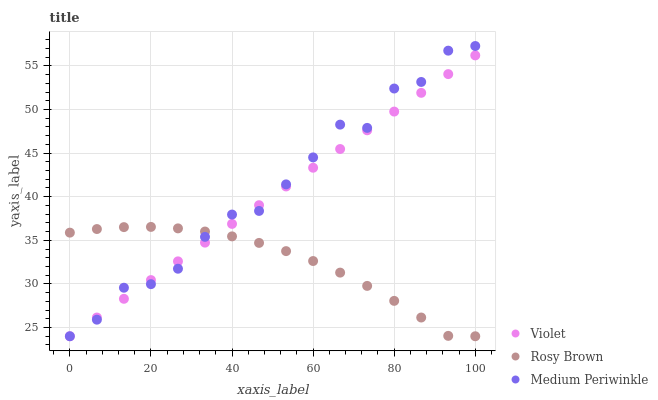Does Rosy Brown have the minimum area under the curve?
Answer yes or no. Yes. Does Medium Periwinkle have the maximum area under the curve?
Answer yes or no. Yes. Does Violet have the minimum area under the curve?
Answer yes or no. No. Does Violet have the maximum area under the curve?
Answer yes or no. No. Is Violet the smoothest?
Answer yes or no. Yes. Is Medium Periwinkle the roughest?
Answer yes or no. Yes. Is Medium Periwinkle the smoothest?
Answer yes or no. No. Is Violet the roughest?
Answer yes or no. No. Does Rosy Brown have the lowest value?
Answer yes or no. Yes. Does Medium Periwinkle have the highest value?
Answer yes or no. Yes. Does Violet have the highest value?
Answer yes or no. No. Does Violet intersect Rosy Brown?
Answer yes or no. Yes. Is Violet less than Rosy Brown?
Answer yes or no. No. Is Violet greater than Rosy Brown?
Answer yes or no. No. 